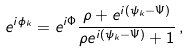<formula> <loc_0><loc_0><loc_500><loc_500>e ^ { i \phi _ { k } } = e ^ { i \Phi } \frac { \rho + e ^ { i ( \psi _ { k } - \Psi ) } } { \rho e ^ { i ( \psi _ { k } - \Psi ) } + 1 } \, ,</formula> 